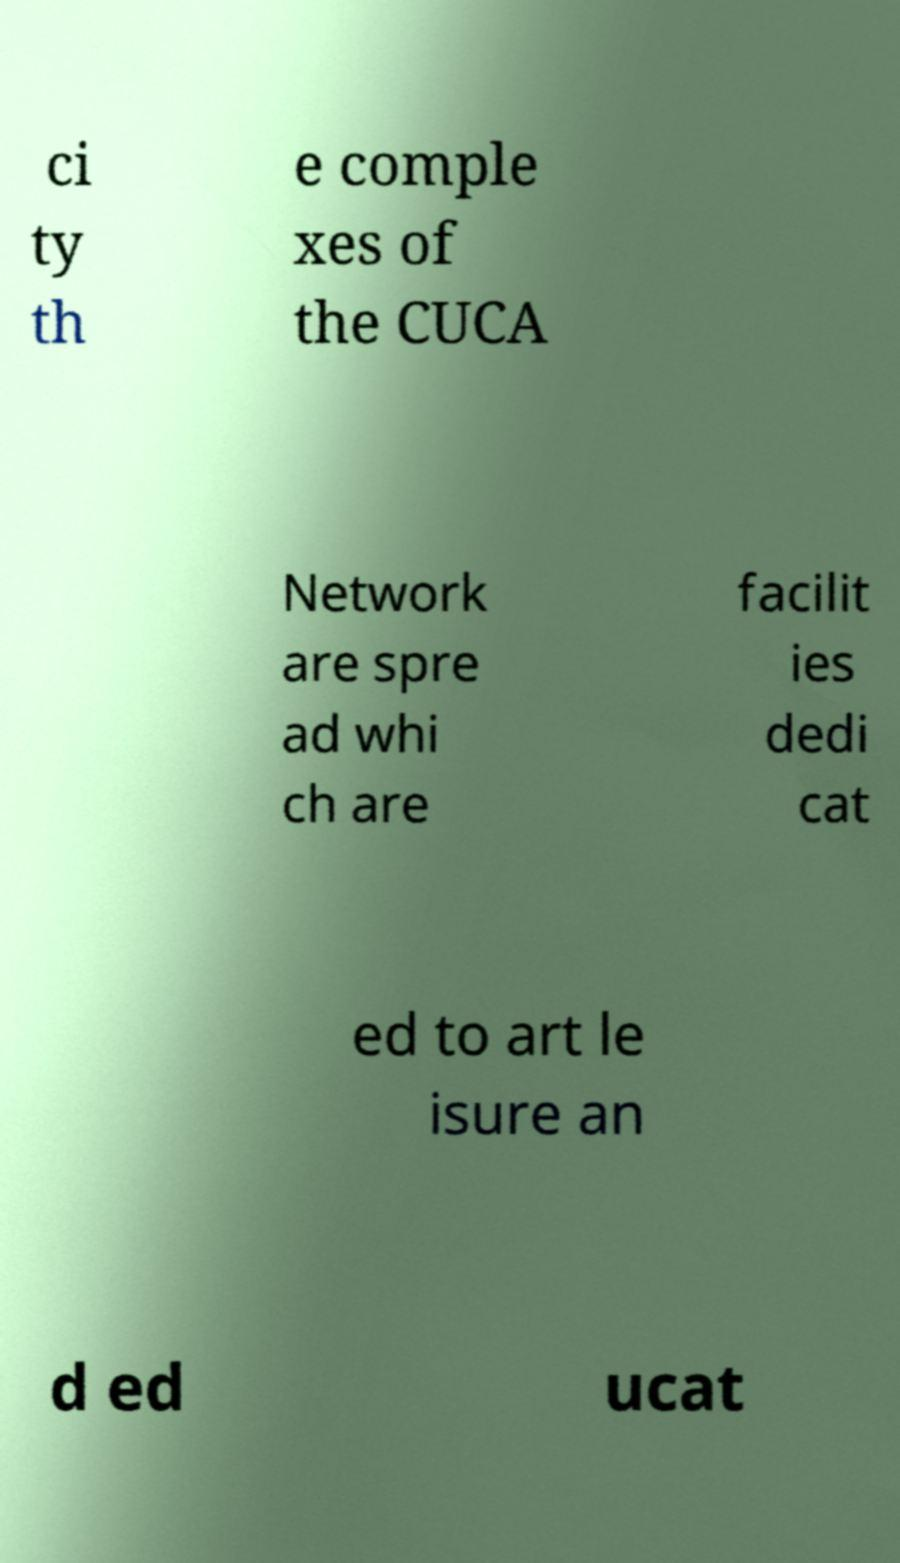There's text embedded in this image that I need extracted. Can you transcribe it verbatim? ci ty th e comple xes of the CUCA Network are spre ad whi ch are facilit ies dedi cat ed to art le isure an d ed ucat 